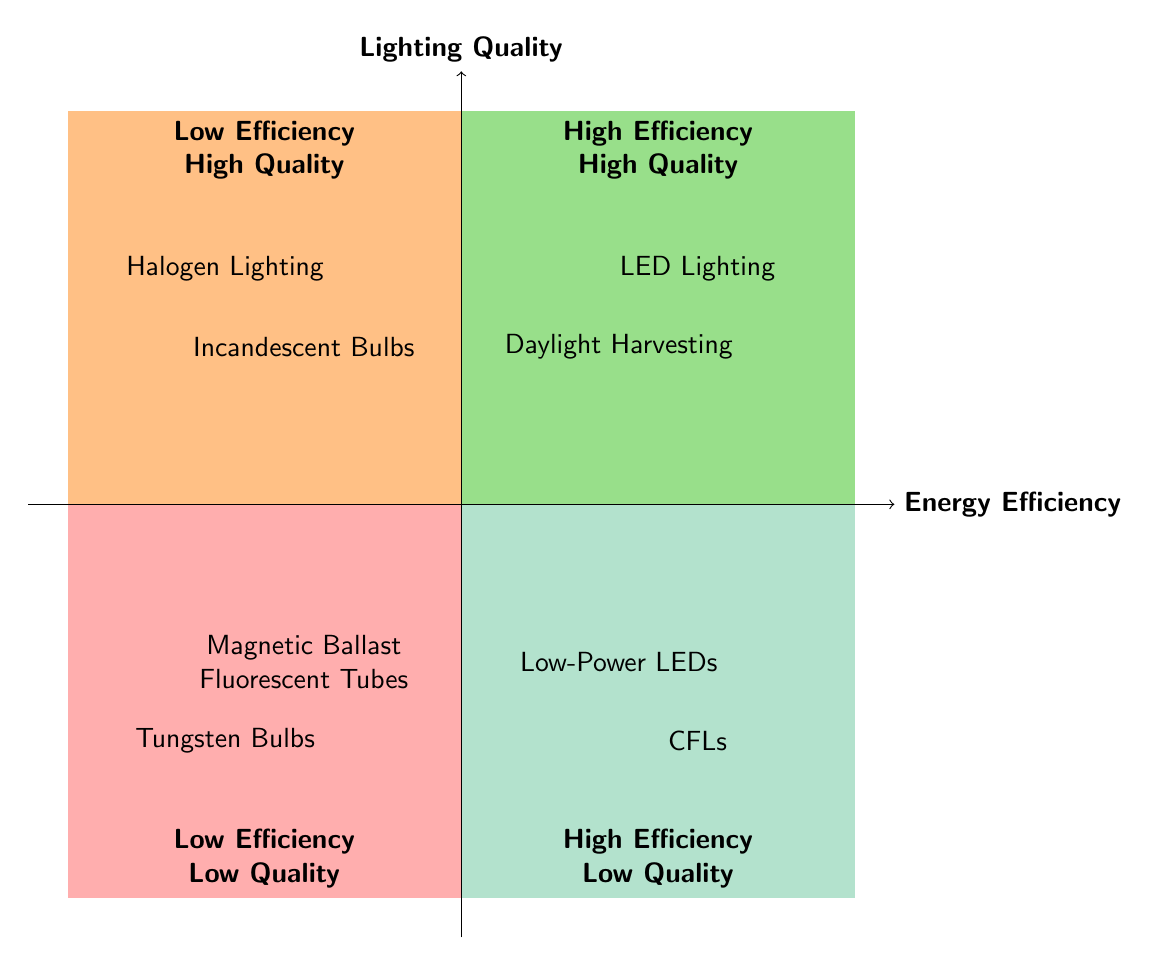What are the two lighting options in the High Energy Efficiency - High Lighting Quality quadrant? The diagram indicates two specific lighting options in this quadrant: LED Lighting and Daylight Harvesting. These are located in the top-right section of the quadrant chart, where both attributes—energy efficiency and lighting quality—are high.
Answer: LED Lighting, Daylight Harvesting Which quadrant contains Incandescent Bulbs? According to the diagram, Incandescent Bulbs are located in the Low Energy Efficiency - High Lighting Quality quadrant. This quadrant is in the top-left section, indicating that while they provide high-quality light, they are not energy efficient.
Answer: Low Energy Efficiency - High Lighting Quality How many lighting options are categorized under Low Energy Efficiency - Low Lighting Quality? The diagram shows two lighting options in the Low Energy Efficiency - Low Lighting Quality quadrant: Tungsten Bulbs and Magnetic Ballast Fluorescent Tubes. Thus, the count of options in this quadrant is two.
Answer: 2 What is the primary characteristic of the High Energy Efficiency - Low Lighting Quality quadrant? In this quadrant, both listed lighting types, Compact Fluorescent Lights (CFLs) and Low-Power LEDs, are marked by their high energy efficiency but low lighting quality. This captures the essence of this quadrant’s primary characteristic.
Answer: High energy efficiency but low lighting quality Which lighting option has excellent color rendering but consumes more energy? The diagram identifies Halogen Lighting in the Low Energy Efficiency - High Lighting Quality quadrant as having excellent color rendering while also being a high energy consumer, fitting the description provided.
Answer: Halogen Lighting 